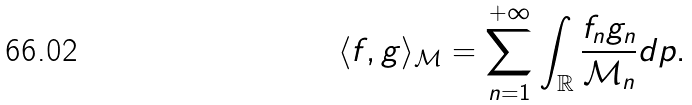Convert formula to latex. <formula><loc_0><loc_0><loc_500><loc_500>\langle f , g \rangle _ { \mathcal { M } } = \sum _ { n = 1 } ^ { + \infty } \int _ { \mathbb { R } } \frac { f _ { n } g _ { n } } { \mathcal { M } _ { n } } d p .</formula> 